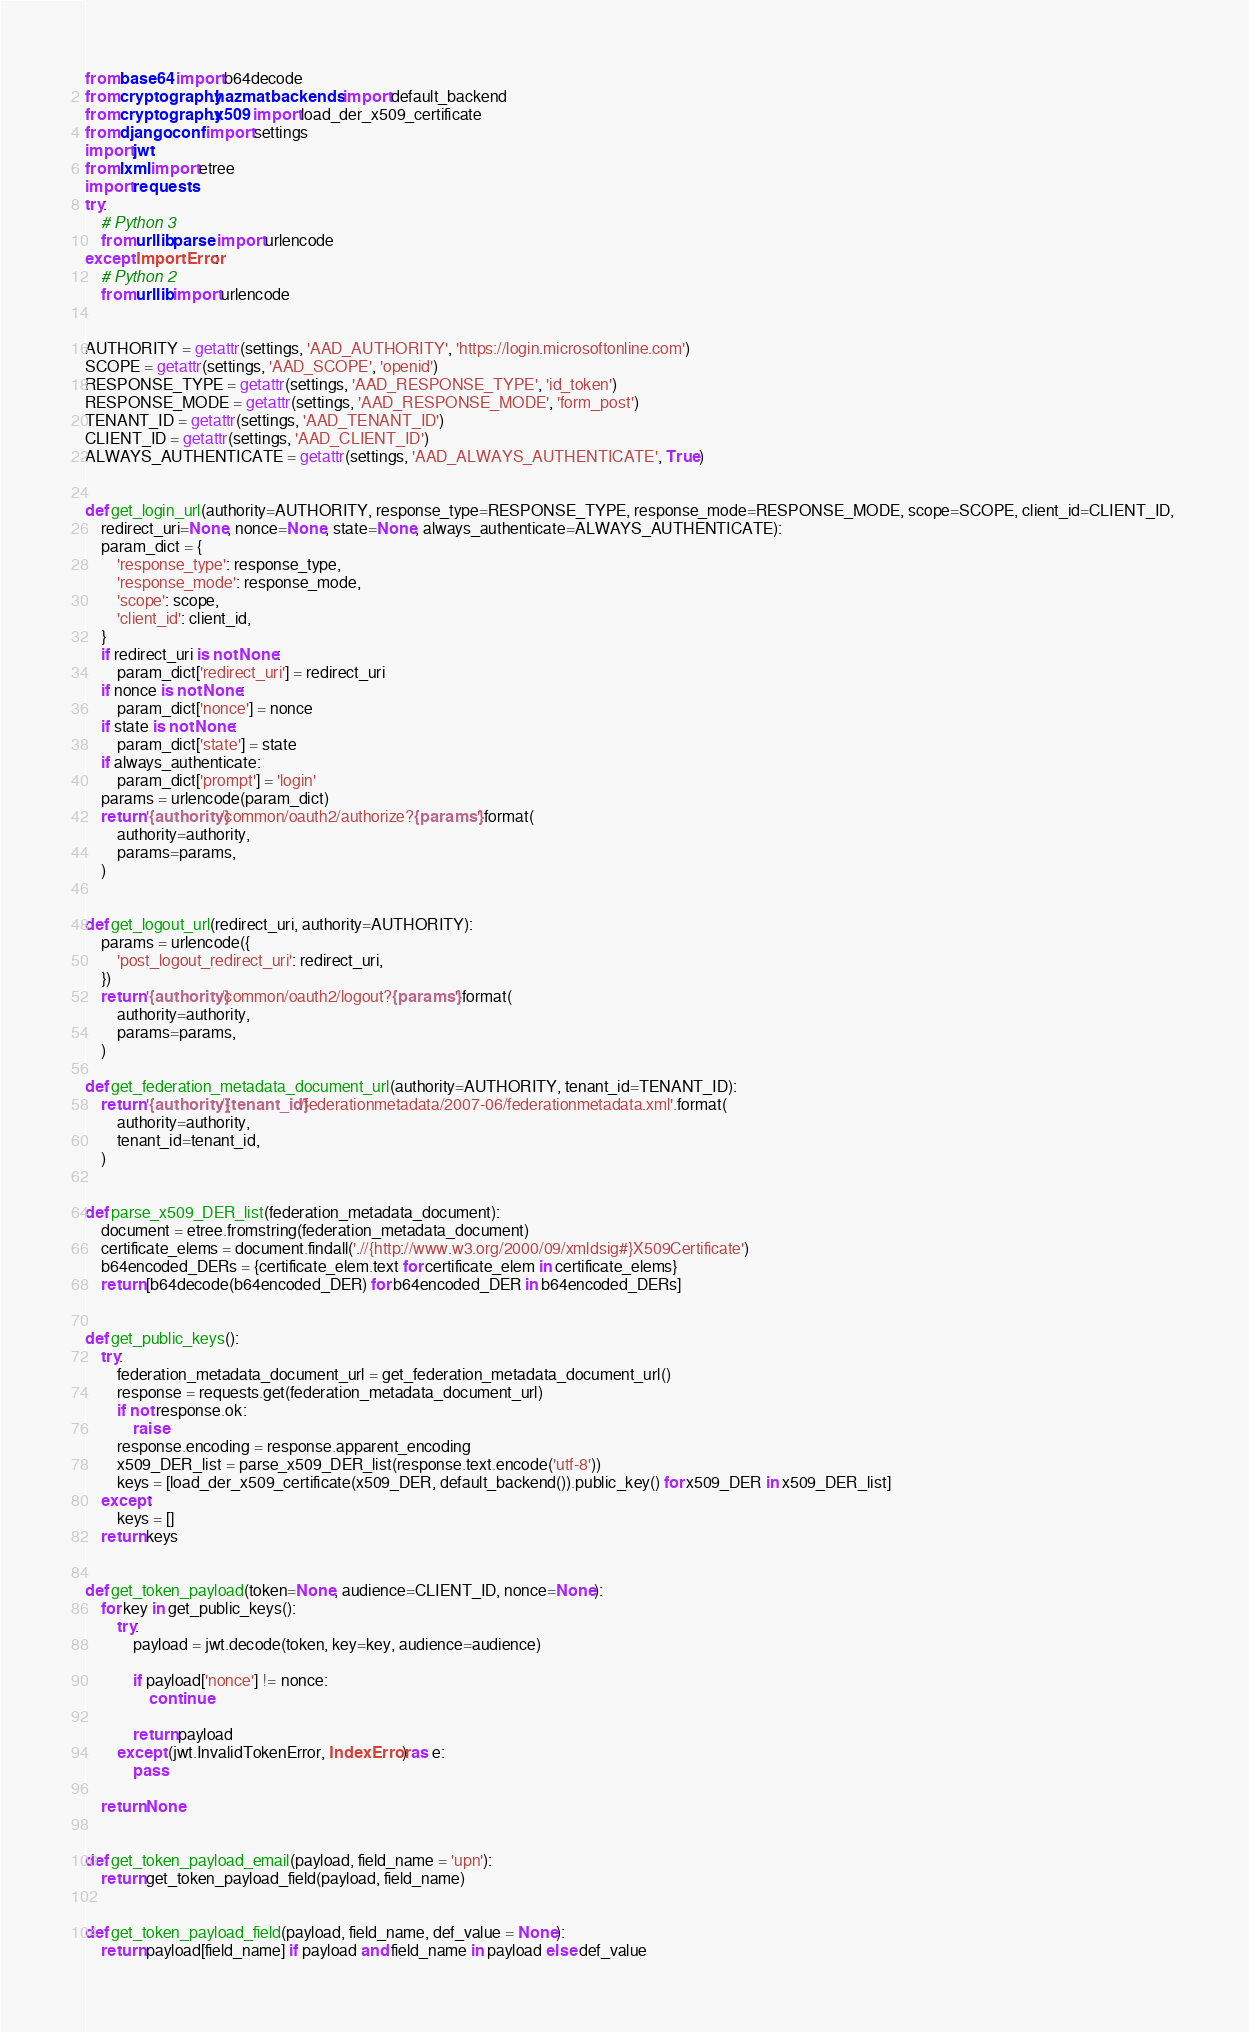Convert code to text. <code><loc_0><loc_0><loc_500><loc_500><_Python_>from base64 import b64decode
from cryptography.hazmat.backends import default_backend
from cryptography.x509 import load_der_x509_certificate
from django.conf import settings
import jwt
from lxml import etree
import requests
try:
    # Python 3
    from urllib.parse import urlencode
except ImportError:
    # Python 2
    from urllib import urlencode


AUTHORITY = getattr(settings, 'AAD_AUTHORITY', 'https://login.microsoftonline.com')
SCOPE = getattr(settings, 'AAD_SCOPE', 'openid')
RESPONSE_TYPE = getattr(settings, 'AAD_RESPONSE_TYPE', 'id_token')
RESPONSE_MODE = getattr(settings, 'AAD_RESPONSE_MODE', 'form_post')
TENANT_ID = getattr(settings, 'AAD_TENANT_ID')
CLIENT_ID = getattr(settings, 'AAD_CLIENT_ID')
ALWAYS_AUTHENTICATE = getattr(settings, 'AAD_ALWAYS_AUTHENTICATE', True)


def get_login_url(authority=AUTHORITY, response_type=RESPONSE_TYPE, response_mode=RESPONSE_MODE, scope=SCOPE, client_id=CLIENT_ID, 
    redirect_uri=None, nonce=None, state=None, always_authenticate=ALWAYS_AUTHENTICATE):
    param_dict = {
        'response_type': response_type,
        'response_mode': response_mode,
        'scope': scope,
        'client_id': client_id,
    }
    if redirect_uri is not None:
        param_dict['redirect_uri'] = redirect_uri
    if nonce is not None:
        param_dict['nonce'] = nonce
    if state is not None:
        param_dict['state'] = state
    if always_authenticate:
        param_dict['prompt'] = 'login'
    params = urlencode(param_dict)
    return '{authority}/common/oauth2/authorize?{params}'.format(
        authority=authority,
        params=params,
    )


def get_logout_url(redirect_uri, authority=AUTHORITY):
    params = urlencode({
        'post_logout_redirect_uri': redirect_uri,
    })
    return '{authority}/common/oauth2/logout?{params}'.format(
        authority=authority,
        params=params,
    )

def get_federation_metadata_document_url(authority=AUTHORITY, tenant_id=TENANT_ID):
    return '{authority}/{tenant_id}/federationmetadata/2007-06/federationmetadata.xml'.format(
        authority=authority,
        tenant_id=tenant_id,
    )


def parse_x509_DER_list(federation_metadata_document):
    document = etree.fromstring(federation_metadata_document)
    certificate_elems = document.findall('.//{http://www.w3.org/2000/09/xmldsig#}X509Certificate')
    b64encoded_DERs = {certificate_elem.text for certificate_elem in certificate_elems}
    return [b64decode(b64encoded_DER) for b64encoded_DER in b64encoded_DERs]


def get_public_keys():
    try:
        federation_metadata_document_url = get_federation_metadata_document_url()
        response = requests.get(federation_metadata_document_url)
        if not response.ok:
            raise
        response.encoding = response.apparent_encoding
        x509_DER_list = parse_x509_DER_list(response.text.encode('utf-8'))
        keys = [load_der_x509_certificate(x509_DER, default_backend()).public_key() for x509_DER in x509_DER_list]
    except:
        keys = []
    return keys


def get_token_payload(token=None, audience=CLIENT_ID, nonce=None):
    for key in get_public_keys():
        try:
            payload = jwt.decode(token, key=key, audience=audience)

            if payload['nonce'] != nonce:
                continue

            return payload
        except (jwt.InvalidTokenError, IndexError) as e:
            pass

    return None


def get_token_payload_email(payload, field_name = 'upn'):
    return get_token_payload_field(payload, field_name)


def get_token_payload_field(payload, field_name, def_value = None):
    return payload[field_name] if payload and field_name in payload else def_value

</code> 